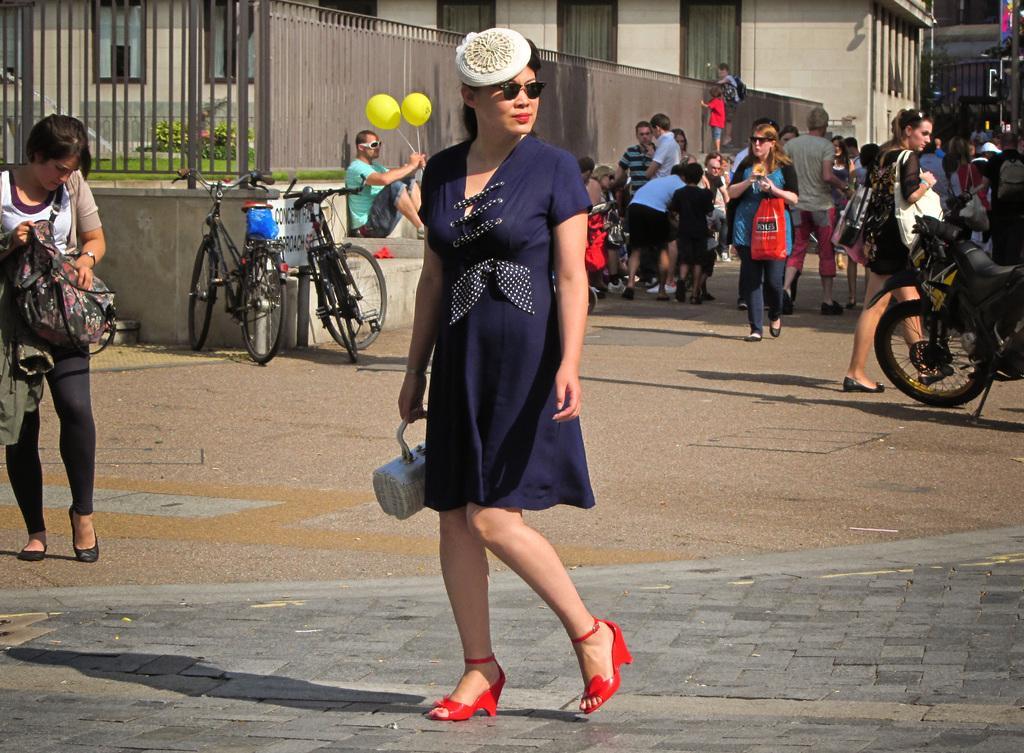Describe this image in one or two sentences. In the image there is a woman in the foreground and behind her there are few other people, vehicles and in the background there is a building. 